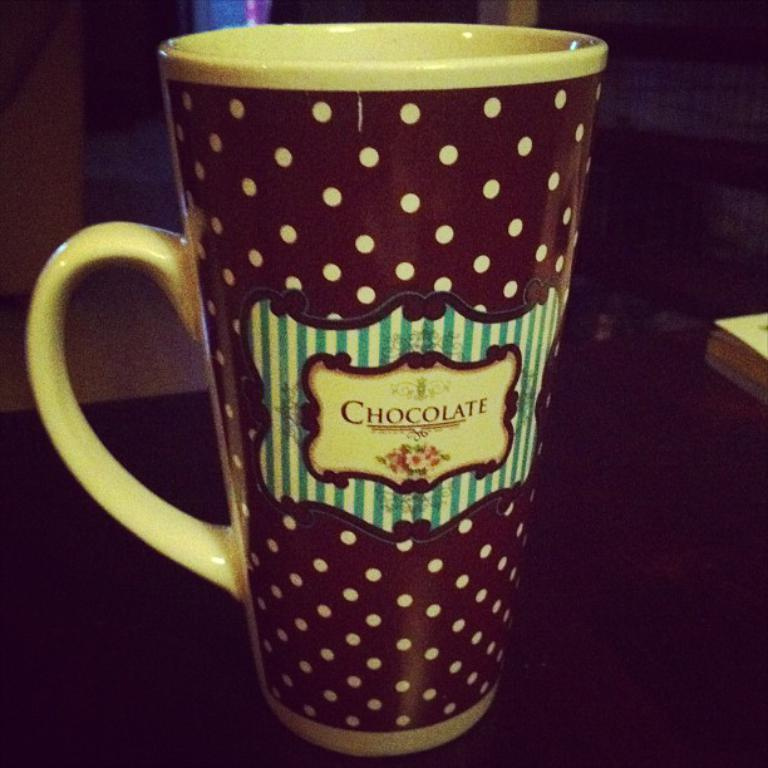Provide a one-sentence caption for the provided image. large coffee cup with the words choclate written acrross. 